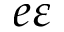Convert formula to latex. <formula><loc_0><loc_0><loc_500><loc_500>e \varepsilon</formula> 